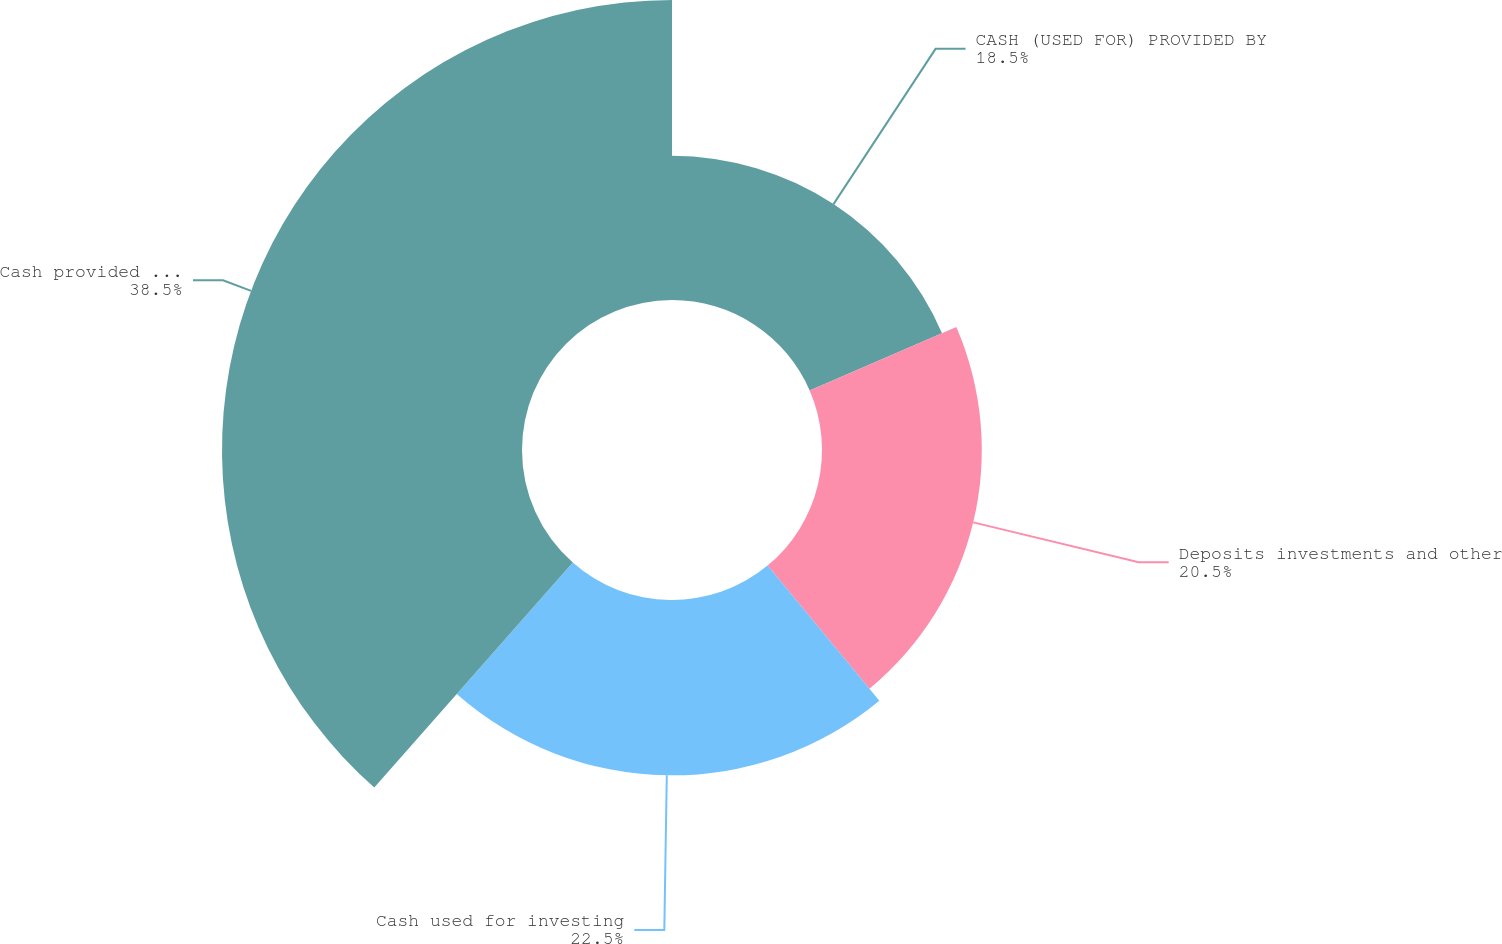Convert chart. <chart><loc_0><loc_0><loc_500><loc_500><pie_chart><fcel>CASH (USED FOR) PROVIDED BY<fcel>Deposits investments and other<fcel>Cash used for investing<fcel>Cash provided by financing<nl><fcel>18.5%<fcel>20.5%<fcel>22.5%<fcel>38.49%<nl></chart> 